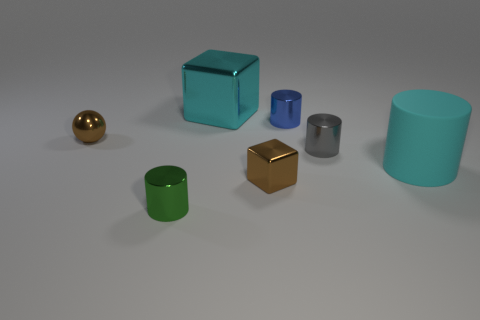Which objects in the image could fit inside the teal cylinder if it were hollow? Assuming the teal cylinder is hollow, both the gold sphere and the small green cylinder have a smaller diameter and could potentially fit inside it. The silver cylinder is roughly the same height but with a smaller diameter, so it could also fit inside the teal cylinder. The cubes, however, appear to have dimensions that would prevent them from fitting inside the teal cylinder due to their height and width. 